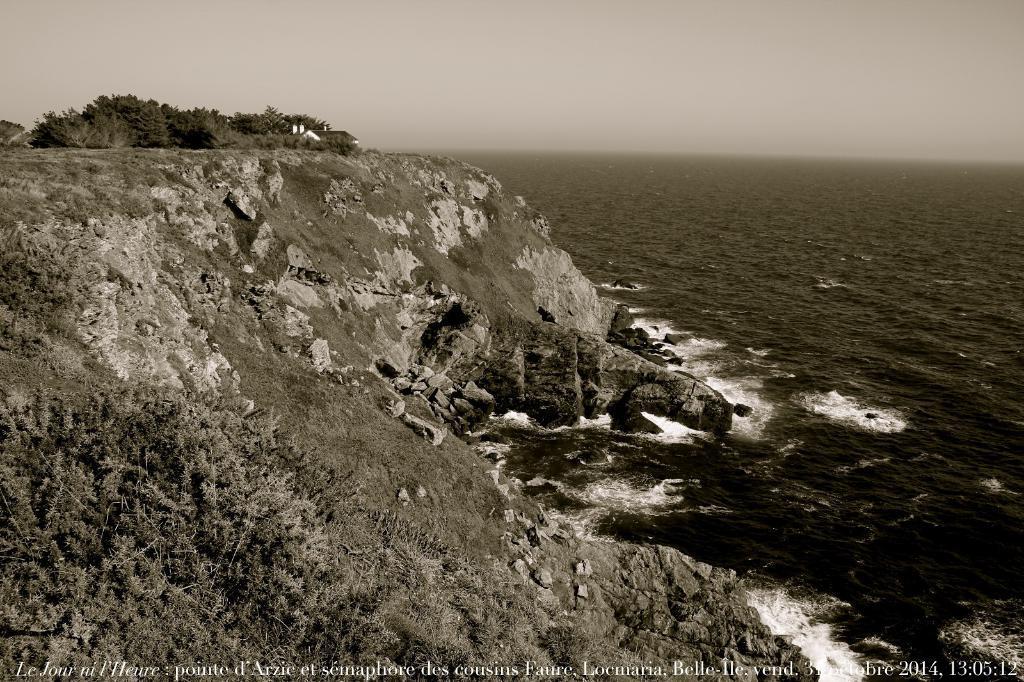In one or two sentences, can you explain what this image depicts? In this black and white picture there is a hill having few rocks, trees and few plants on it. On hill there is a house. Beside hill there is water having some tides. Top of image there is sky. 